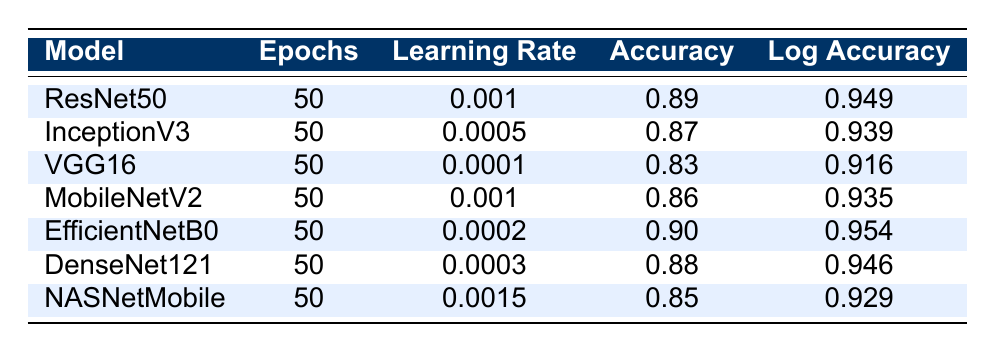What is the accuracy of EfficientNetB0? The accuracy of EfficientNetB0 can be found in the table directly under the "Accuracy" column corresponding to the "EfficientNetB0" row, which is 0.90.
Answer: 0.90 Which model has the highest log accuracy? By comparing the "Log Accuracy" values for all models, we find that EfficientNetB0 has the highest log accuracy of 0.954.
Answer: EfficientNetB0 What is the difference between the accuracy of ResNet50 and VGG16? To find the difference, we subtract the accuracy of VGG16 (0.83) from ResNet50 (0.89): 0.89 - 0.83 = 0.06.
Answer: 0.06 Is the learning rate of NASNetMobile higher than that of DenseNet121? The learning rate for NASNetMobile is 0.0015, while for DenseNet121 it is 0.0003. Since 0.0015 is greater than 0.0003, the statement is true.
Answer: Yes What is the average learning rate of all models listed? We add the learning rates of all models: 0.001 + 0.0005 + 0.0001 + 0.001 + 0.0002 + 0.0003 + 0.0015 = 0.0046. There are 7 models, so we divide by 7: 0.0046 / 7 = 0.000657.
Answer: 0.000657 Which model has the lowest accuracy and what is its value? By checking the "Accuracy" column for the lowest value, we see that VGG16 has the lowest accuracy of 0.83.
Answer: VGG16, 0.83 How many models have an accuracy greater than 0.85? Looking at the accuracy values: ResNet50 (0.89), InceptionV3 (0.87), MobileNetV2 (0.86), EfficientNetB0 (0.90), and DenseNet121 (0.88) are all greater than 0.85, resulting in 5 models.
Answer: 5 Is the log accuracy for MobileNetV2 greater than that of InceptionV3? The log accuracy for MobileNetV2 is 0.935 and for InceptionV3 it is 0.939. Since 0.935 is not greater than 0.939, the statement is false.
Answer: No What is the log accuracy of the model with the highest learning rate? The model with the highest learning rate is NASNetMobile (0.0015), and its log accuracy is 0.929, as can be found in the table.
Answer: 0.929 